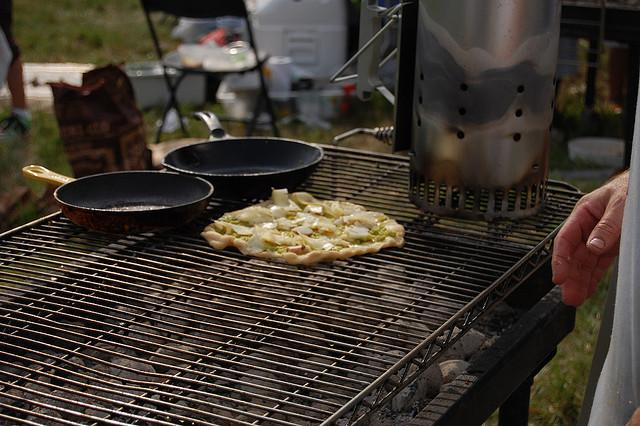Where is the item being grilled normally prepared? Please explain your reasoning. oven. A pizza is on a grill. pizzas are traditionally cooked in ovens. 